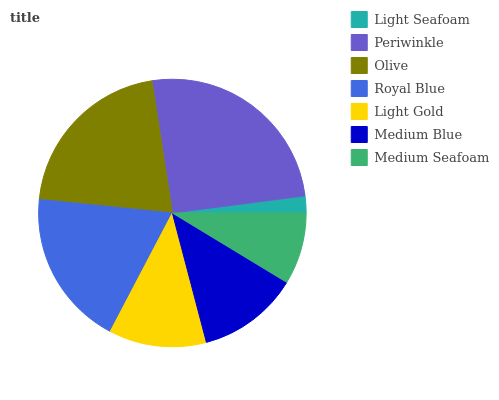Is Light Seafoam the minimum?
Answer yes or no. Yes. Is Periwinkle the maximum?
Answer yes or no. Yes. Is Olive the minimum?
Answer yes or no. No. Is Olive the maximum?
Answer yes or no. No. Is Periwinkle greater than Olive?
Answer yes or no. Yes. Is Olive less than Periwinkle?
Answer yes or no. Yes. Is Olive greater than Periwinkle?
Answer yes or no. No. Is Periwinkle less than Olive?
Answer yes or no. No. Is Medium Blue the high median?
Answer yes or no. Yes. Is Medium Blue the low median?
Answer yes or no. Yes. Is Periwinkle the high median?
Answer yes or no. No. Is Royal Blue the low median?
Answer yes or no. No. 